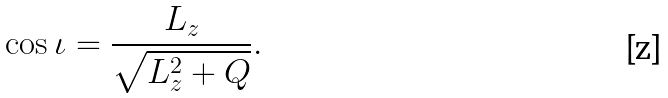Convert formula to latex. <formula><loc_0><loc_0><loc_500><loc_500>\cos \iota = \frac { L _ { z } } { \sqrt { L _ { z } ^ { 2 } + Q } } .</formula> 